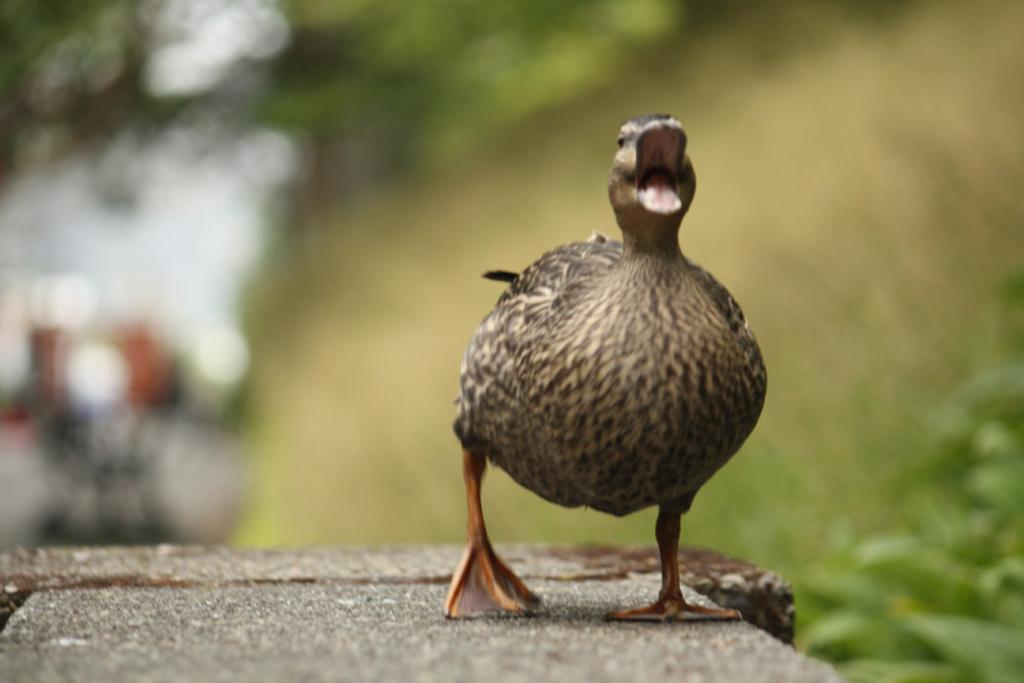What animal is present in the image? There is a duck in the image. What is the duck standing on? The duck is standing on a stone. What type of vegetation can be seen in the background of the image? There is a group of plants and trees in the background of the image. What part of the natural environment is visible in the background of the image? The sky is visible in the background of the image. Can you see any visible veins on the duck in the image? There are no visible veins on the duck in the image, as it is a photograph of a duck and not a medical illustration. How many kittens are playing with the duck in the image? There are no kittens present in the image; it features a duck standing on a stone. 